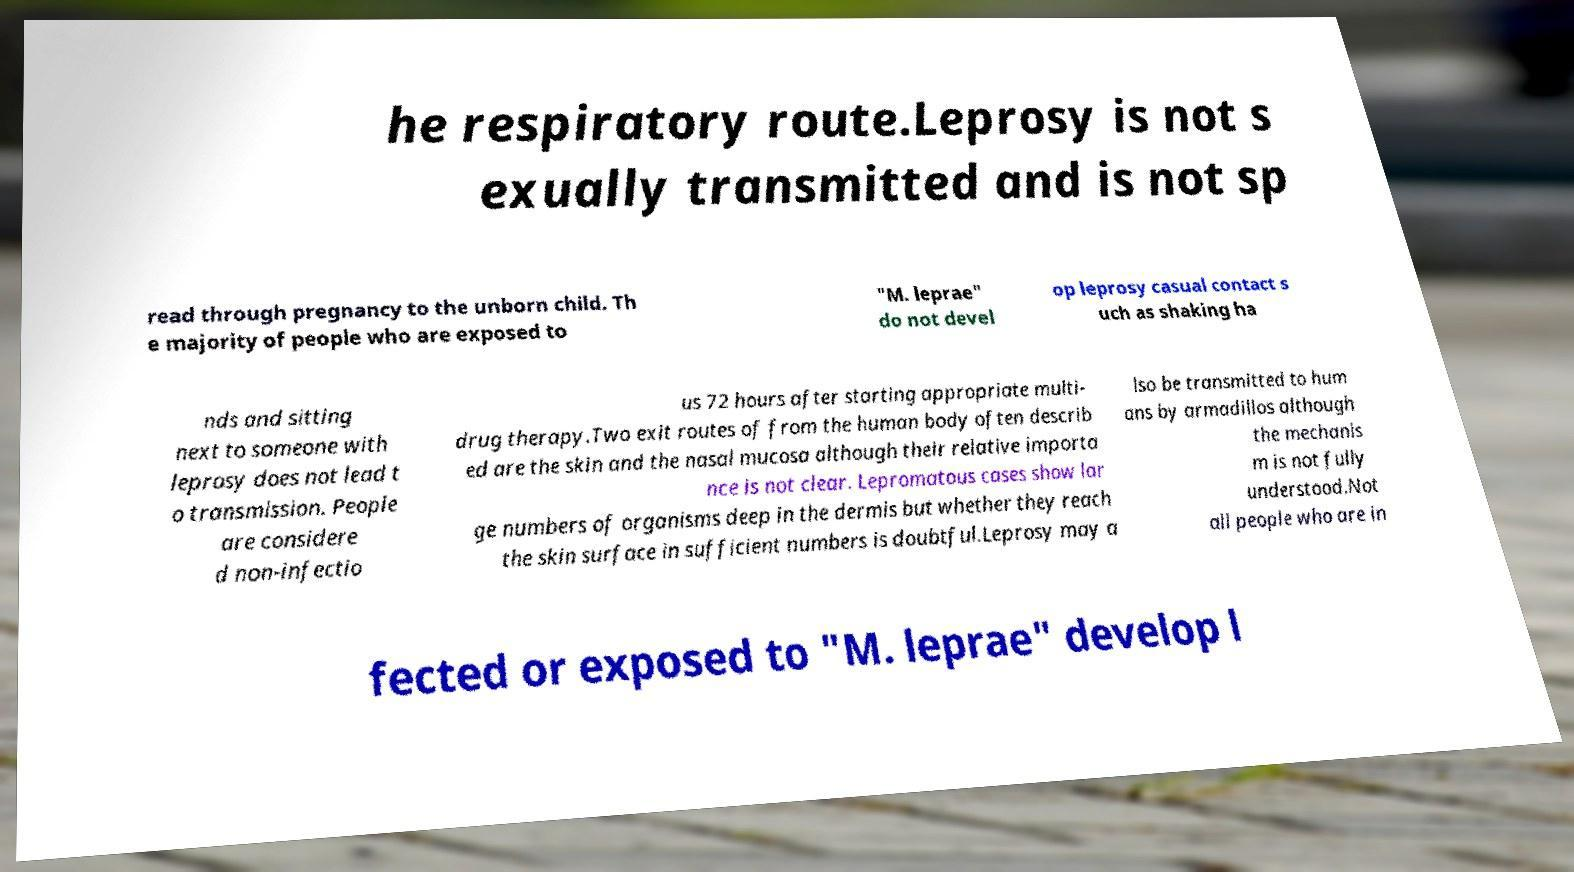Please identify and transcribe the text found in this image. he respiratory route.Leprosy is not s exually transmitted and is not sp read through pregnancy to the unborn child. Th e majority of people who are exposed to "M. leprae" do not devel op leprosy casual contact s uch as shaking ha nds and sitting next to someone with leprosy does not lead t o transmission. People are considere d non-infectio us 72 hours after starting appropriate multi- drug therapy.Two exit routes of from the human body often describ ed are the skin and the nasal mucosa although their relative importa nce is not clear. Lepromatous cases show lar ge numbers of organisms deep in the dermis but whether they reach the skin surface in sufficient numbers is doubtful.Leprosy may a lso be transmitted to hum ans by armadillos although the mechanis m is not fully understood.Not all people who are in fected or exposed to "M. leprae" develop l 